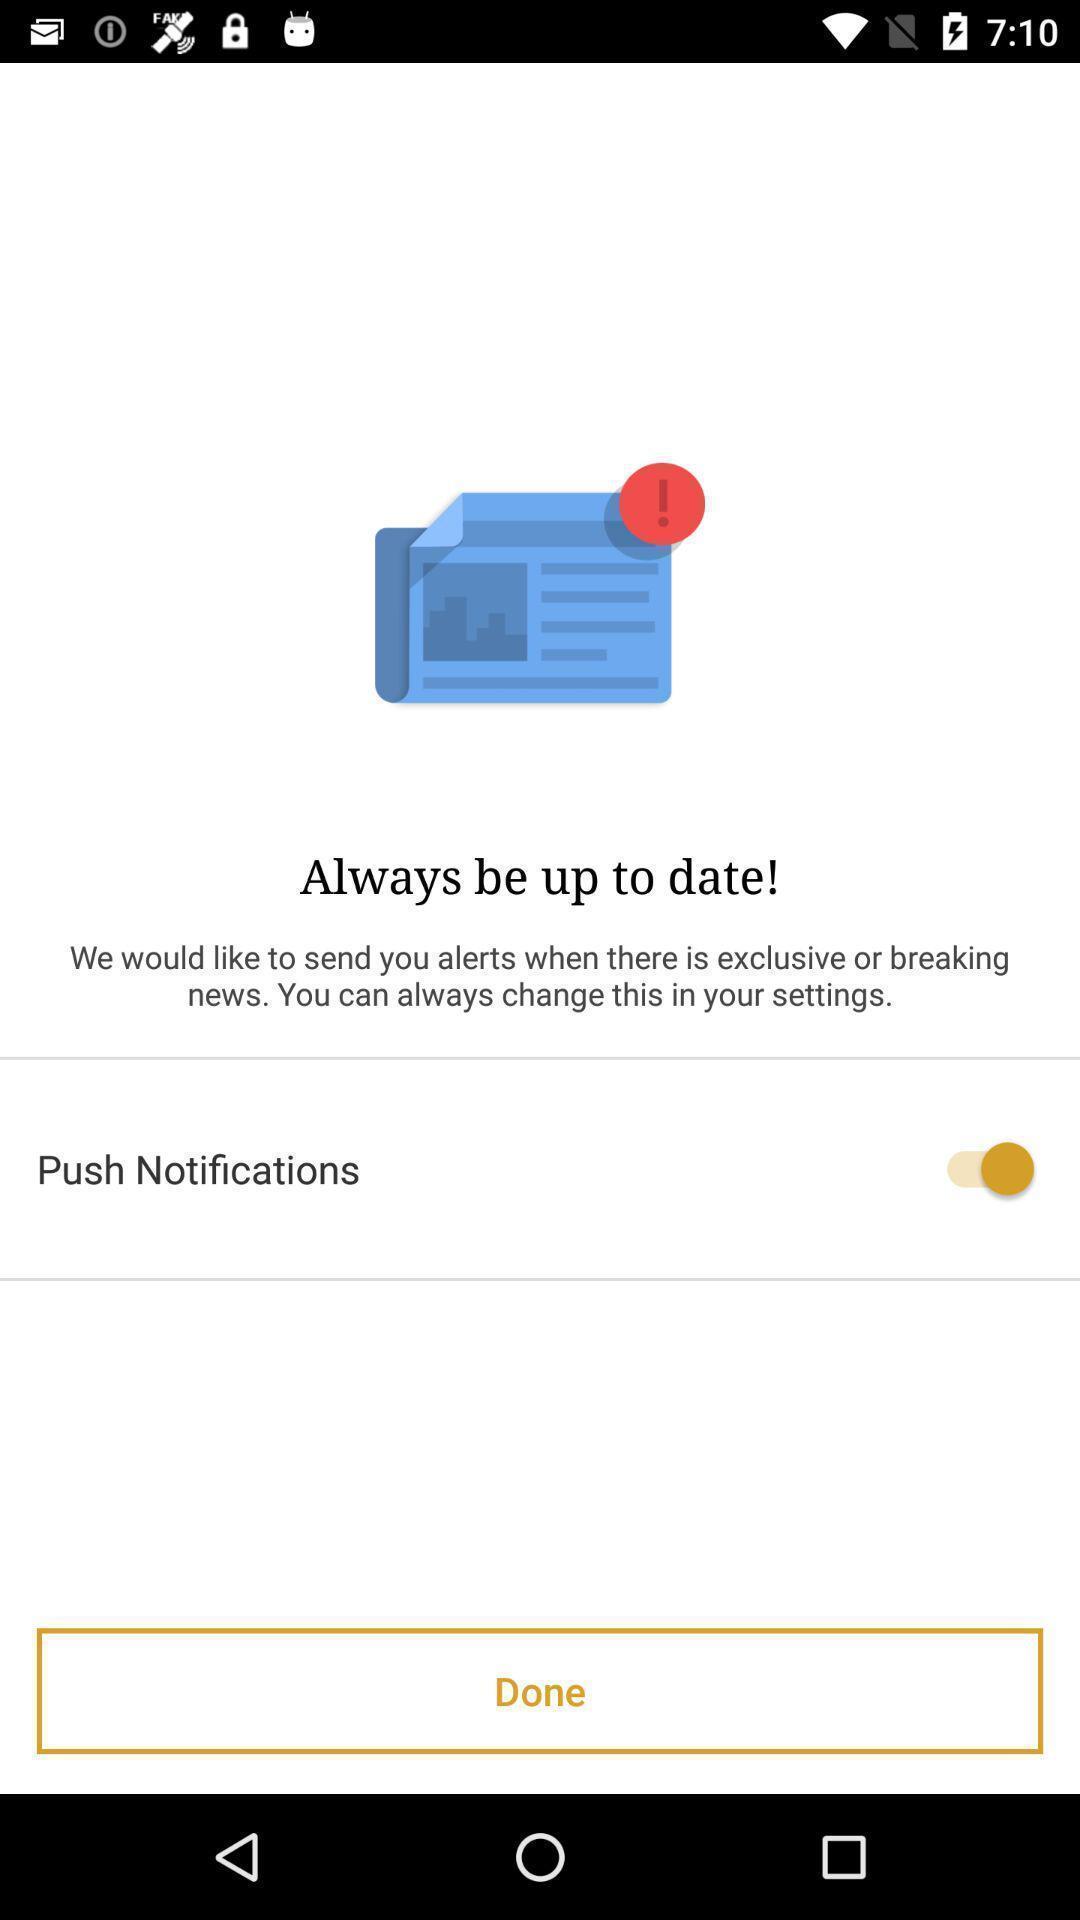Explain the elements present in this screenshot. Page showing push notifications option with alert info. 